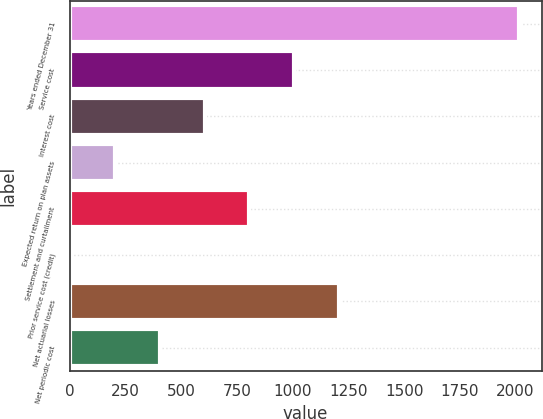Convert chart. <chart><loc_0><loc_0><loc_500><loc_500><bar_chart><fcel>Years ended December 31<fcel>Service cost<fcel>Interest cost<fcel>Expected return on plan assets<fcel>Settlement and curtailment<fcel>Prior service cost (credit)<fcel>Net actuarial losses<fcel>Net periodic cost<nl><fcel>2016<fcel>1008.1<fcel>604.94<fcel>201.78<fcel>806.52<fcel>0.2<fcel>1209.68<fcel>403.36<nl></chart> 